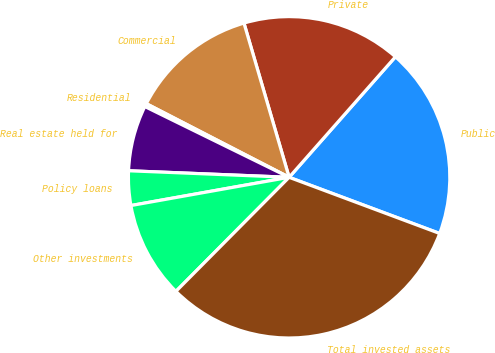Convert chart. <chart><loc_0><loc_0><loc_500><loc_500><pie_chart><fcel>Public<fcel>Private<fcel>Commercial<fcel>Residential<fcel>Real estate held for<fcel>Policy loans<fcel>Other investments<fcel>Total invested assets<nl><fcel>19.18%<fcel>16.04%<fcel>12.89%<fcel>0.32%<fcel>6.61%<fcel>3.46%<fcel>9.75%<fcel>31.76%<nl></chart> 